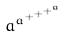Convert formula to latex. <formula><loc_0><loc_0><loc_500><loc_500>a ^ { a ^ { + ^ { + ^ { + ^ { a } } } } }</formula> 